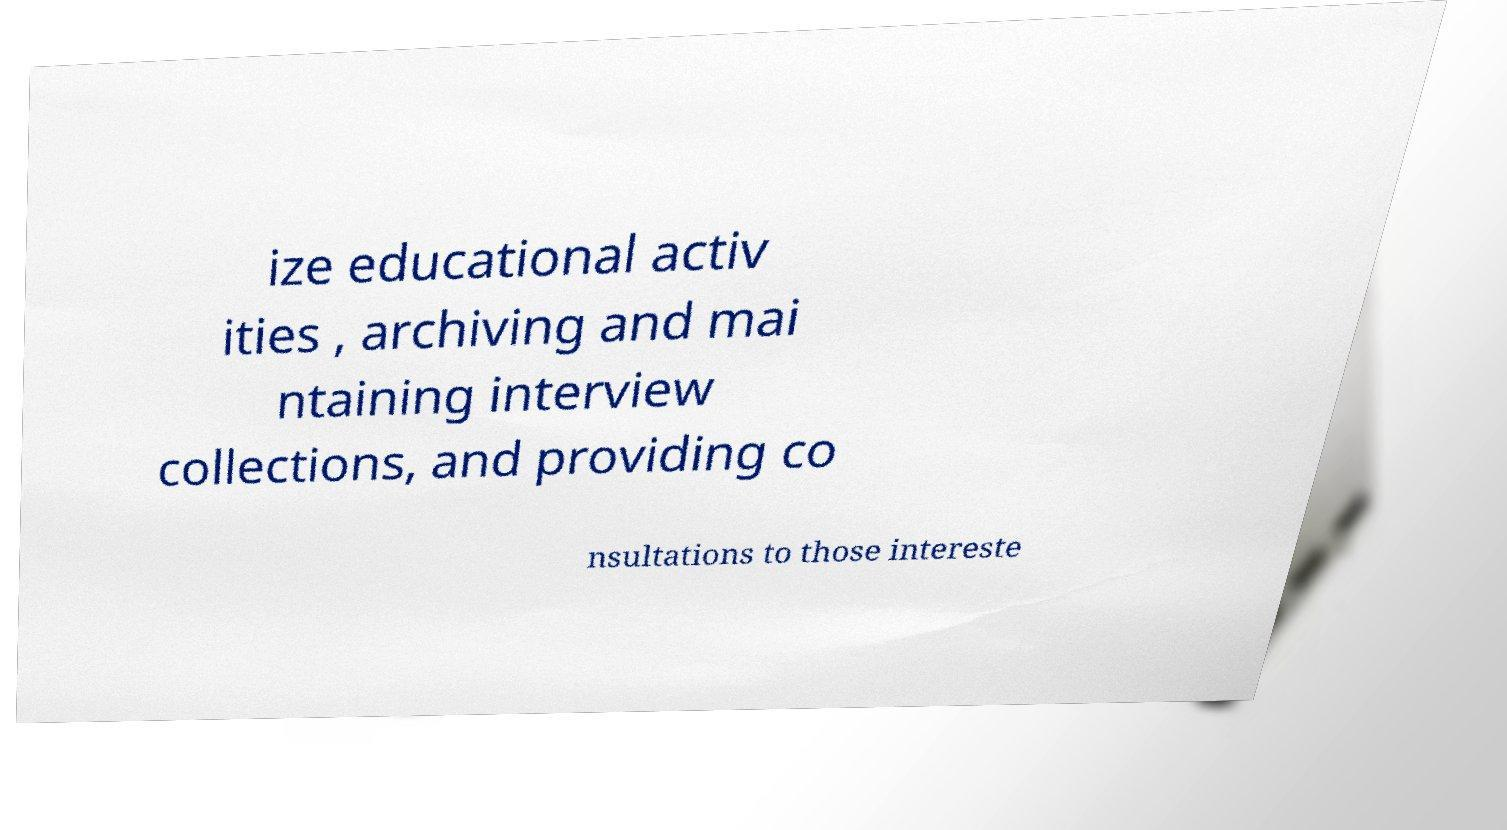Can you accurately transcribe the text from the provided image for me? ize educational activ ities , archiving and mai ntaining interview collections, and providing co nsultations to those intereste 